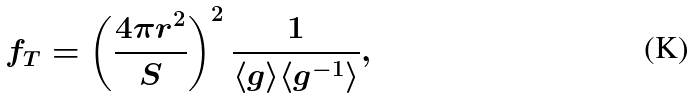<formula> <loc_0><loc_0><loc_500><loc_500>f _ { T } = \left ( \frac { 4 \pi r ^ { 2 } } { S } \right ) ^ { 2 } \frac { 1 } { \langle g \rangle \langle g ^ { - 1 } \rangle } ,</formula> 